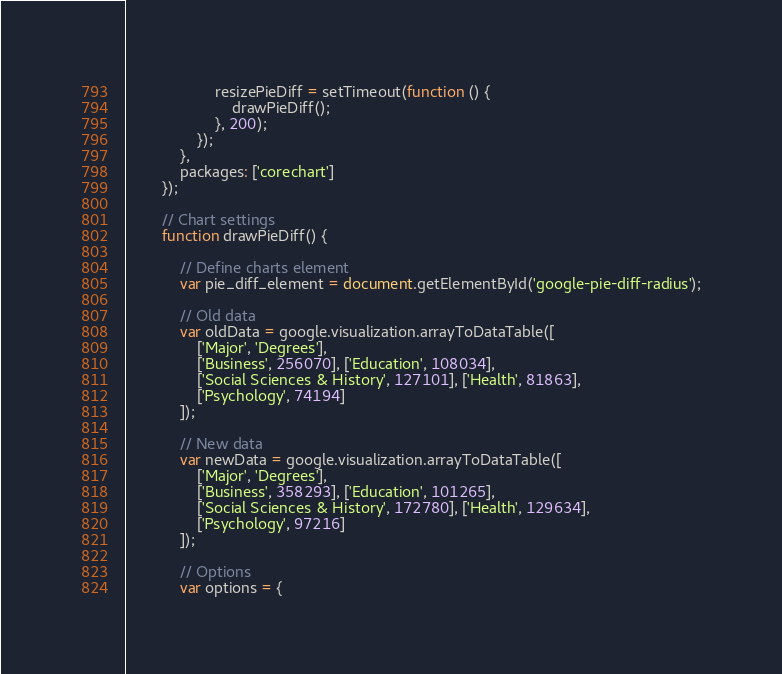Convert code to text. <code><loc_0><loc_0><loc_500><loc_500><_JavaScript_>                    resizePieDiff = setTimeout(function () {
                        drawPieDiff();
                    }, 200);
                });
            },
            packages: ['corechart']
        });

        // Chart settings
        function drawPieDiff() {

            // Define charts element
            var pie_diff_element = document.getElementById('google-pie-diff-radius');

            // Old data
            var oldData = google.visualization.arrayToDataTable([
                ['Major', 'Degrees'],
                ['Business', 256070], ['Education', 108034],
                ['Social Sciences & History', 127101], ['Health', 81863],
                ['Psychology', 74194]
            ]);

            // New data
            var newData = google.visualization.arrayToDataTable([
                ['Major', 'Degrees'],
                ['Business', 358293], ['Education', 101265],
                ['Social Sciences & History', 172780], ['Health', 129634],
                ['Psychology', 97216]
            ]);

            // Options
            var options = {</code> 